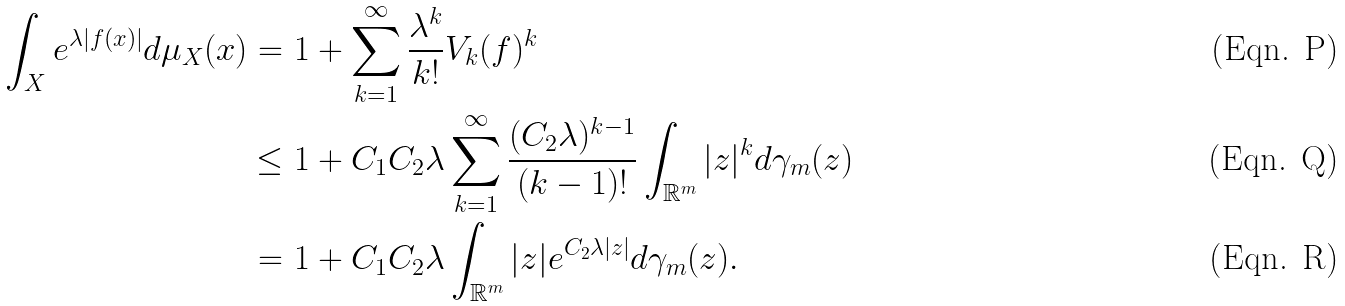Convert formula to latex. <formula><loc_0><loc_0><loc_500><loc_500>\int _ { X } e ^ { \lambda | f ( x ) | } d \mu _ { X } ( x ) = \ & 1 + \sum _ { k = 1 } ^ { \infty } \frac { \lambda ^ { k } } { k ! } V _ { k } ( f ) ^ { k } \\ \leq \ & 1 + C _ { 1 } C _ { 2 } \lambda \sum _ { k = 1 } ^ { \infty } \frac { ( C _ { 2 } \lambda ) ^ { k - 1 } } { ( k - 1 ) ! } \int _ { \mathbb { R } ^ { m } } | z | ^ { k } d \gamma _ { m } ( z ) \\ = \ & 1 + C _ { 1 } C _ { 2 } \lambda \int _ { \mathbb { R } ^ { m } } | z | e ^ { C _ { 2 } \lambda | z | } d \gamma _ { m } ( z ) .</formula> 